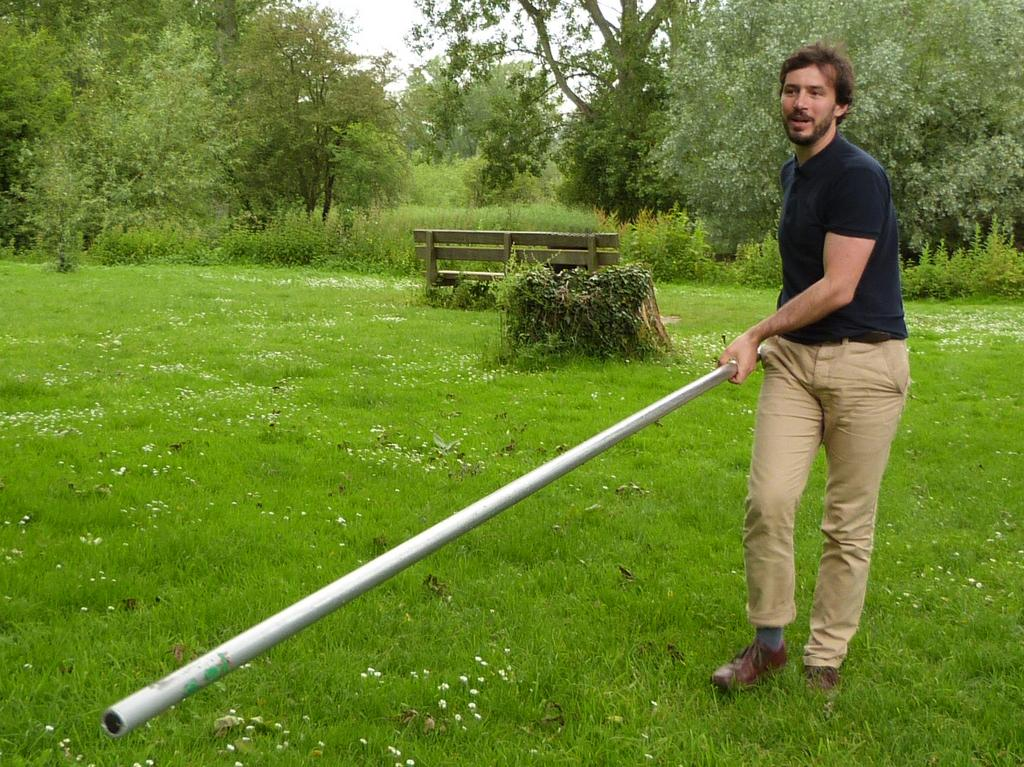What is the main subject of the image? There is a man in the image. What is the man holding in his hand? The man is holding a rod in his hand. What type of environment is depicted in the image? There is grass, trees, and a bench in the image, suggesting an outdoor setting. What can be seen in the background of the image? The sky is visible in the background of the image. What type of tank can be seen in the image? There is no tank present in the image. What is the man using the hook on the rod for in the image? There is no hook on the rod in the image; the man is simply holding a rod. 